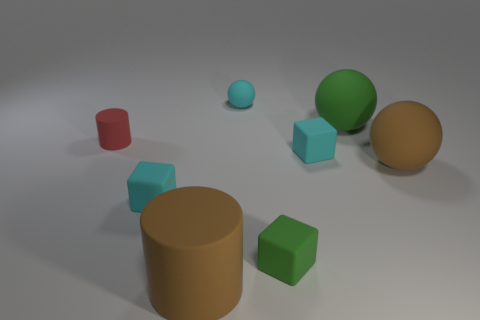There is a small block that is behind the brown sphere; is its color the same as the tiny cylinder?
Provide a short and direct response. No. The small rubber ball is what color?
Provide a succinct answer. Cyan. Are there any tiny cyan objects that are in front of the big matte object behind the tiny red thing?
Your answer should be compact. Yes. What shape is the big matte object on the left side of the green object behind the brown ball?
Make the answer very short. Cylinder. Are there fewer small cyan things than cyan matte balls?
Provide a short and direct response. No. What is the color of the large object that is right of the cyan rubber sphere and in front of the large green object?
Your response must be concise. Brown. Is there a brown matte cylinder that has the same size as the brown sphere?
Keep it short and to the point. Yes. There is a cyan rubber thing behind the cylinder on the left side of the large matte cylinder; how big is it?
Ensure brevity in your answer.  Small. Is the number of tiny objects to the right of the small sphere less than the number of cyan objects?
Ensure brevity in your answer.  Yes. What size is the cyan sphere?
Provide a succinct answer. Small. 